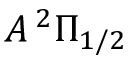Convert formula to latex. <formula><loc_0><loc_0><loc_500><loc_500>A \, ^ { 2 } \Pi _ { 1 / 2 }</formula> 